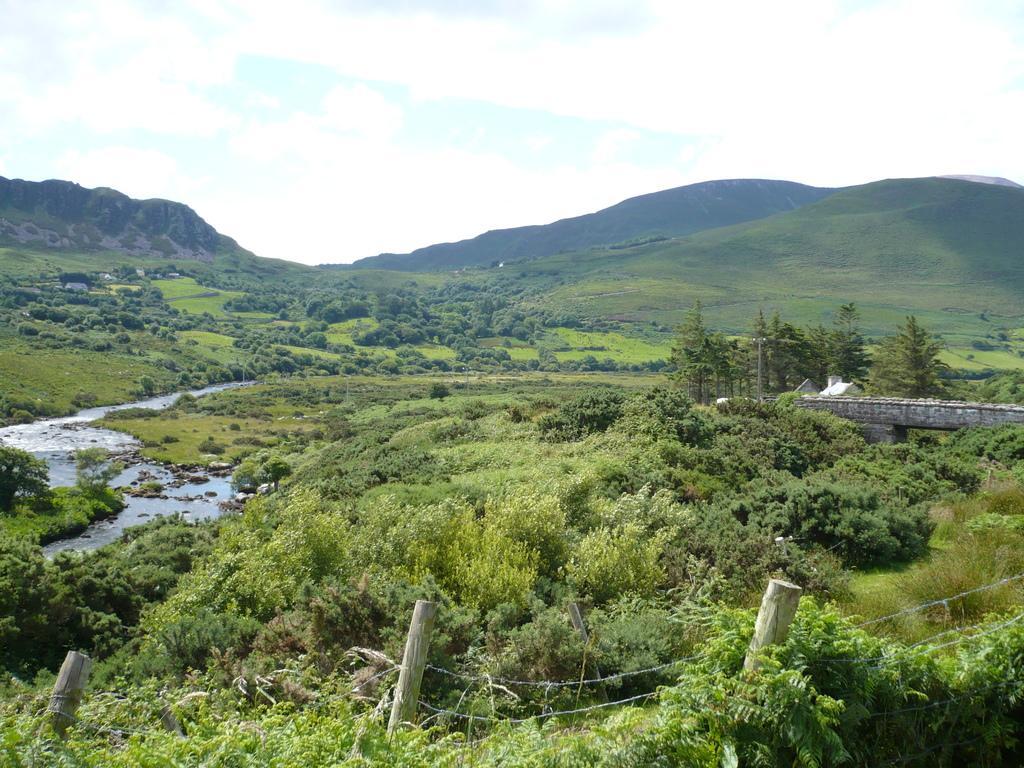In one or two sentences, can you explain what this image depicts? In this picture there is greenery around the area of the image and there are bamboos at the bottom side of the image. 